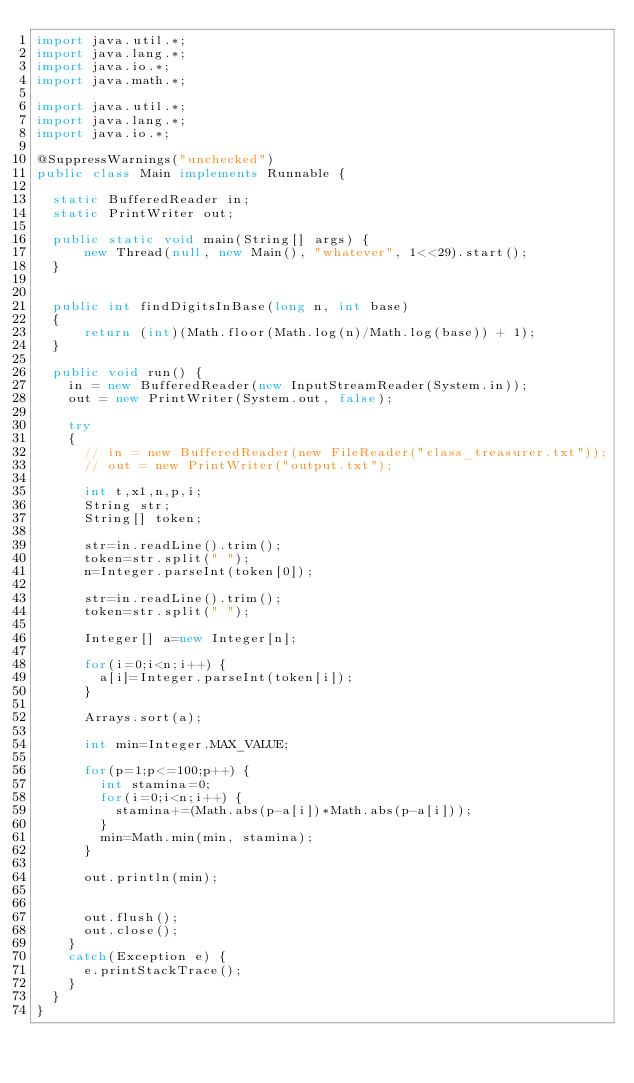<code> <loc_0><loc_0><loc_500><loc_500><_Java_>import java.util.*;
import java.lang.*;
import java.io.*;
import java.math.*;
 
import java.util.*;
import java.lang.*;
import java.io.*;

@SuppressWarnings("unchecked")
public class Main implements Runnable {

  static BufferedReader in;
  static PrintWriter out;
 
  public static void main(String[] args) {
      new Thread(null, new Main(), "whatever", 1<<29).start();
  }


  public int findDigitsInBase(long n, int base) 
  { 
      return (int)(Math.floor(Math.log(n)/Math.log(base)) + 1);  
  } 
 
  public void run() {
    in = new BufferedReader(new InputStreamReader(System.in));
    out = new PrintWriter(System.out, false);
 
    try
    {
      // in = new BufferedReader(new FileReader("class_treasurer.txt"));
      // out = new PrintWriter("output.txt");

      int t,x1,n,p,i;
      String str;
      String[] token;

      str=in.readLine().trim();
      token=str.split(" ");
      n=Integer.parseInt(token[0]);

      str=in.readLine().trim();
      token=str.split(" ");

      Integer[] a=new Integer[n];

      for(i=0;i<n;i++) {
        a[i]=Integer.parseInt(token[i]);
      }

      Arrays.sort(a);

      int min=Integer.MAX_VALUE;

      for(p=1;p<=100;p++) {
        int stamina=0;
        for(i=0;i<n;i++) {
          stamina+=(Math.abs(p-a[i])*Math.abs(p-a[i]));
        }
        min=Math.min(min, stamina);
      }

      out.println(min);


      out.flush();
      out.close();
    }
    catch(Exception e) {
      e.printStackTrace();
    }
  }
}
</code> 